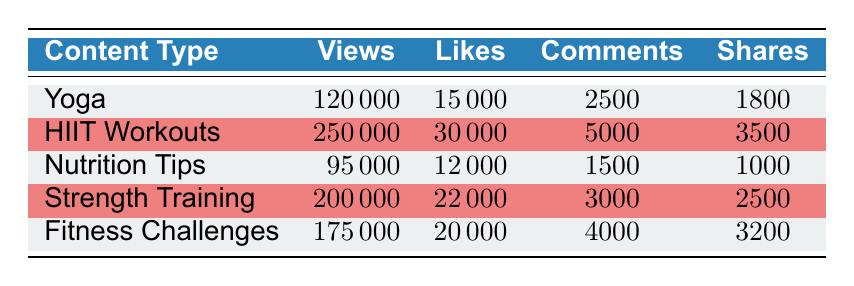What's the highest number of views among the content types? The views for each content type are as follows: Yoga has 120000, HIIT Workouts has 250000, Nutrition Tips has 95000, Strength Training has 200000, and Fitness Challenges has 175000. The highest among these is 250000 for HIIT Workouts.
Answer: 250000 Which content type received the most likes? Looking at the likes for each content type, Yoga has 15000, HIIT Workouts has 30000, Nutrition Tips has 12000, Strength Training has 22000, and Fitness Challenges has 20000. The most likes, therefore, is 30000 for HIIT Workouts.
Answer: 30000 What are the total shares for all content types combined? To find the total shares, we sum up the shares from each content type: Yoga has 1800, HIIT Workouts has 3500, Nutrition Tips has 1000, Strength Training has 2500, and Fitness Challenges has 3200. The total is 1800 + 3500 + 1000 + 2500 + 3200 = 12000.
Answer: 12000 Is it true that Nutrition Tips has more views than Fitness Challenges? Nutrition Tips has 95000 views, while Fitness Challenges has 175000 views. Since 95000 is less than 175000, it is false that Nutrition Tips has more views than Fitness Challenges.
Answer: No What is the average number of comments across all content types? The comments for each type are: Yoga 2500, HIIT Workouts 5000, Nutrition Tips 1500, Strength Training 3000, and Fitness Challenges 4000. Summing these gives 2500 + 5000 + 1500 + 3000 + 4000 = 16000. Dividing this by 5 (the number of content types) gives an average of 16000 / 5 = 3200.
Answer: 3200 Which type had the least number of views, and what was the number? The views are as follows: Yoga 120000, HIIT Workouts 250000, Nutrition Tips 95000, Strength Training 200000, and Fitness Challenges 175000. The least number of views is 95000 for Nutrition Tips.
Answer: Nutrition Tips with 95000 views How many more likes did Strength Training receive than Nutrition Tips? Strength Training has 22000 likes, while Nutrition Tips has 12000 likes. The difference is 22000 - 12000 = 10000.
Answer: 10000 Which content type had the highest engagement in terms of shares? The shares are: Yoga 1800, HIIT Workouts 3500, Nutrition Tips 1000, Strength Training 2500, and Fitness Challenges 3200. The highest shares are from HIIT Workouts with 3500.
Answer: HIIT Workouts 